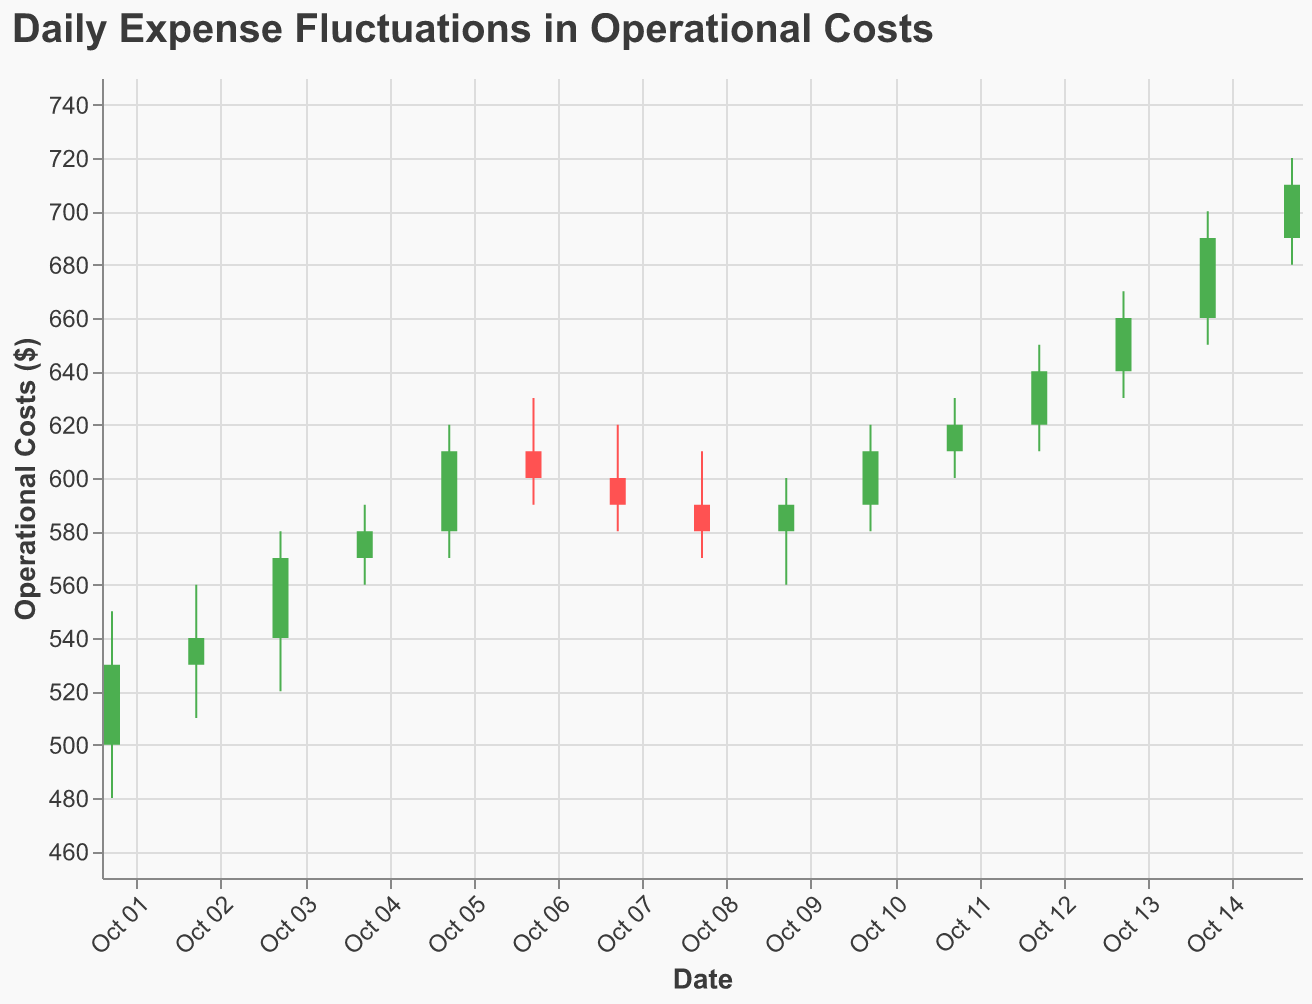What's the range of operational costs on 2023-10-01? The range is given by the difference between the high and low values for that date. High is 550 and low is 480, so the range is 550 - 480 = 70.
Answer: 70 What is the closing operational cost on 2023-10-15? The closing operational cost is given by the "Close" value for that date. For 2023-10-15, the closing cost is 710.
Answer: 710 How many days did the operational costs close higher than they opened? Count the number of days where the "Close" value is higher than the "Open" value. There are 10 such days: Oct 01, Oct 02, Oct 03, Oct 04, Oct 05, Oct 08, Oct 10, Oct 11, Oct 12, Oct 13, Oct 14, Oct 15.
Answer: 10 Which day had the highest operational cost during the period? The highest operational cost can be identified by looking for the highest "High" value in the data. The highest value is 720 on 2023-10-15.
Answer: 2023-10-15 On which days was the operational cost green (i.e., closed higher than opened)? The operational cost is green if the "Close" value is greater than the "Open" value. These days are: Oct 01, Oct 02, Oct 03, Oct 04, Oct 05, Oct 10, Oct 11, Oct 12, Oct 13, Oct 14, and Oct 15.
Answer: Oct 01, Oct 02, Oct 03, Oct 04, Oct 05, Oct 10, Oct 11, Oct 12, Oct 13, Oct 14, Oct 15 What was the overall trend of operational costs from 2023-10-01 to 2023-10-15? Examine the opening and closing prices of the first and last days. On 2023-10-01, the opening price was 500, and the closing price on 2023-10-15 was 710, indicating an overall upward trend.
Answer: Upward What are the dates with the lowest and highest closing operational costs? The lowest closing cost is on 2023-10-01 (530) and the highest closing cost is on 2023-10-15 (710).
Answer: 2023-10-01, 2023-10-15 What is the average closing operational cost over the period? Sum the closing costs over all the days and divide by the number of days. The total closing costs = 530 + 540 + 570 + 580 + 610 + 600 + 590 + 580 + 590 + 610 + 620 + 640 + 660 + 690 + 710 = 9420. There are 15 days. Therefore, the average is 9420 / 15 = 628.
Answer: 628 